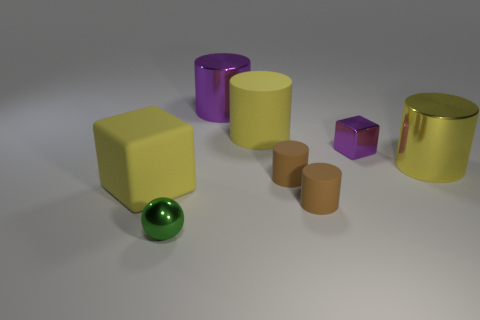Subtract all yellow cylinders. Subtract all green spheres. How many cylinders are left? 3 Add 2 blocks. How many objects exist? 10 Subtract all cylinders. How many objects are left? 3 Add 4 big cyan matte cubes. How many big cyan matte cubes exist? 4 Subtract 1 green spheres. How many objects are left? 7 Subtract all tiny blocks. Subtract all purple metal cylinders. How many objects are left? 6 Add 2 green metallic balls. How many green metallic balls are left? 3 